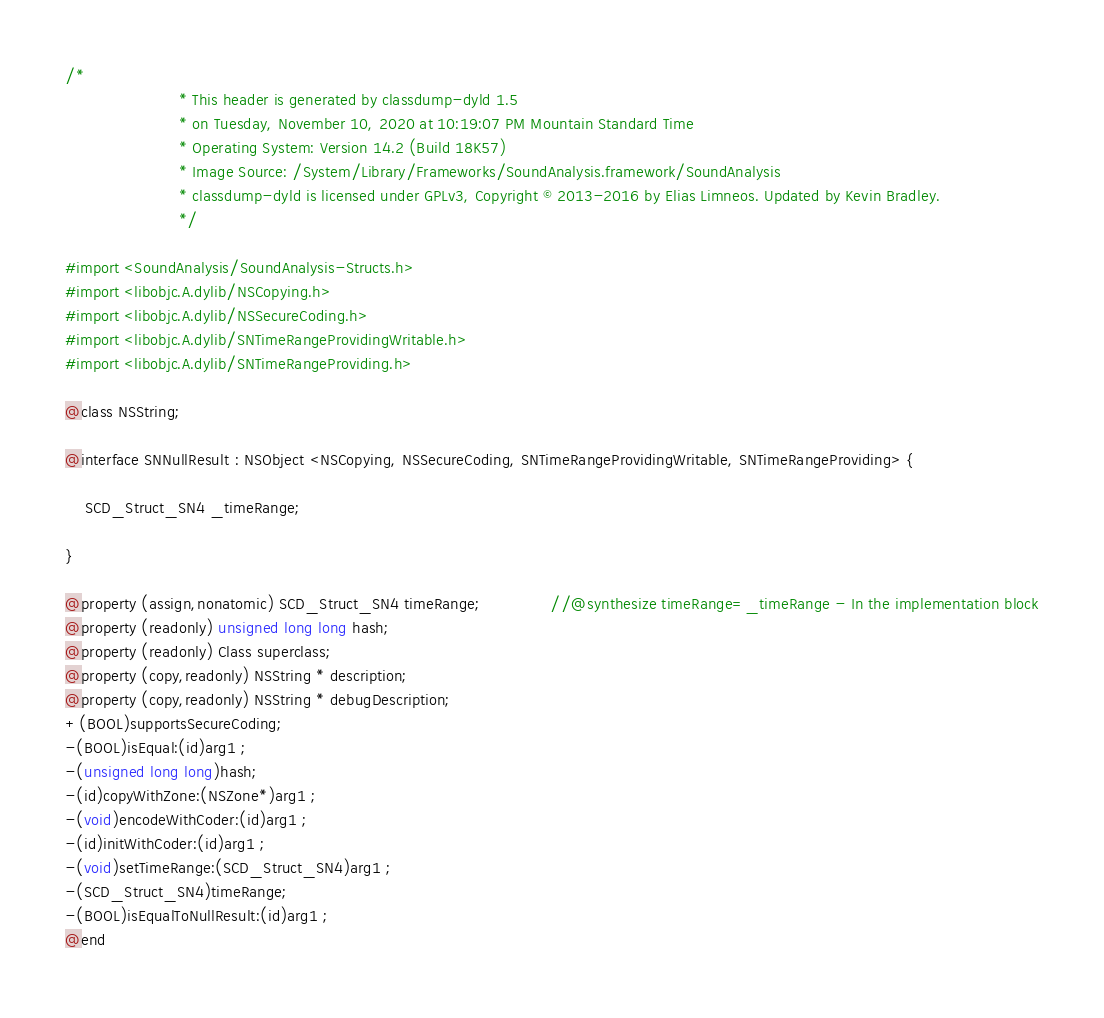<code> <loc_0><loc_0><loc_500><loc_500><_C_>/*
                       * This header is generated by classdump-dyld 1.5
                       * on Tuesday, November 10, 2020 at 10:19:07 PM Mountain Standard Time
                       * Operating System: Version 14.2 (Build 18K57)
                       * Image Source: /System/Library/Frameworks/SoundAnalysis.framework/SoundAnalysis
                       * classdump-dyld is licensed under GPLv3, Copyright © 2013-2016 by Elias Limneos. Updated by Kevin Bradley.
                       */

#import <SoundAnalysis/SoundAnalysis-Structs.h>
#import <libobjc.A.dylib/NSCopying.h>
#import <libobjc.A.dylib/NSSecureCoding.h>
#import <libobjc.A.dylib/SNTimeRangeProvidingWritable.h>
#import <libobjc.A.dylib/SNTimeRangeProviding.h>

@class NSString;

@interface SNNullResult : NSObject <NSCopying, NSSecureCoding, SNTimeRangeProvidingWritable, SNTimeRangeProviding> {

	SCD_Struct_SN4 _timeRange;

}

@property (assign,nonatomic) SCD_Struct_SN4 timeRange;              //@synthesize timeRange=_timeRange - In the implementation block
@property (readonly) unsigned long long hash; 
@property (readonly) Class superclass; 
@property (copy,readonly) NSString * description; 
@property (copy,readonly) NSString * debugDescription; 
+(BOOL)supportsSecureCoding;
-(BOOL)isEqual:(id)arg1 ;
-(unsigned long long)hash;
-(id)copyWithZone:(NSZone*)arg1 ;
-(void)encodeWithCoder:(id)arg1 ;
-(id)initWithCoder:(id)arg1 ;
-(void)setTimeRange:(SCD_Struct_SN4)arg1 ;
-(SCD_Struct_SN4)timeRange;
-(BOOL)isEqualToNullResult:(id)arg1 ;
@end

</code> 